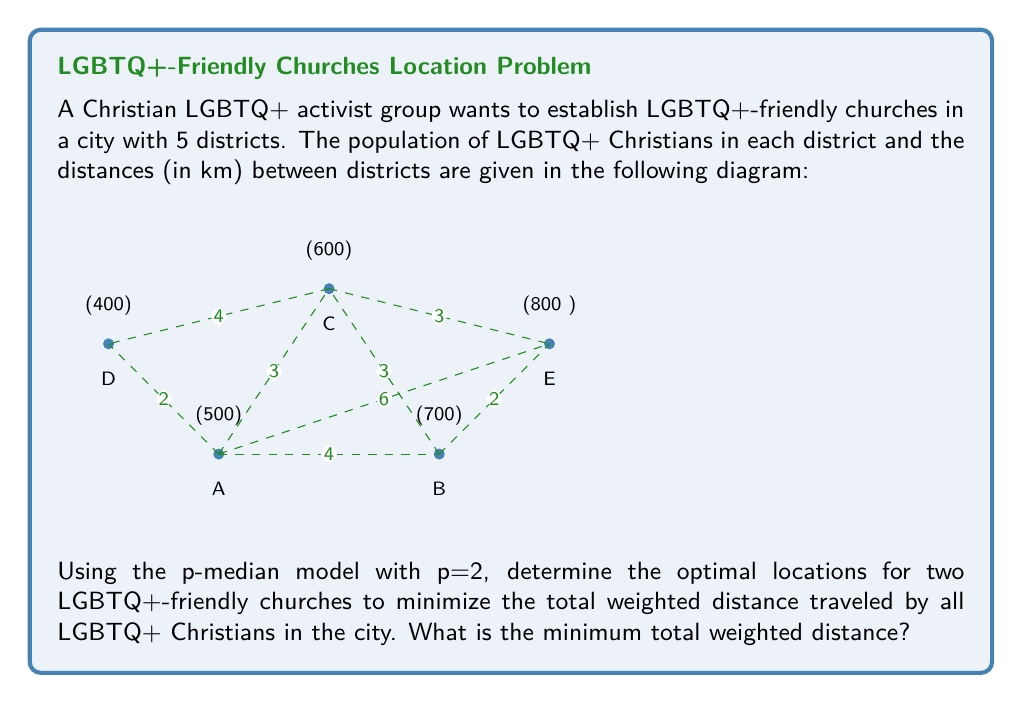Provide a solution to this math problem. To solve this problem using the p-median model, we need to follow these steps:

1) First, we need to calculate the weighted distances for all possible combinations of church locations. The weight for each district is its population.

2) For each combination of two districts as church locations, we calculate:
   $$ \text{Total Weighted Distance} = \sum_{i=1}^5 w_i \cdot \min(d_{i,j}, d_{i,k}) $$
   where $w_i$ is the population of district $i$, and $j$ and $k$ are the chosen church locations.

3) Let's calculate for each combination:

   AB: 500(0) + 700(0) + 600(3) + 400(2) + 800(2) = 4000
   AC: 500(0) + 700(3) + 600(0) + 400(4) + 800(3) = 4900
   AD: 500(0) + 700(4) + 600(3) + 400(0) + 800(6) = 7700
   AE: 500(0) + 700(2) + 600(3) + 400(2) + 800(0) = 3400
   BC: 500(3) + 700(0) + 600(0) + 400(4) + 800(2) = 4100
   BD: 500(4) + 700(0) + 600(3) + 400(2) + 800(2) = 4400
   BE: 500(4) + 700(0) + 600(3) + 400(6) + 800(0) = 5000
   CD: 500(3) + 700(3) + 600(0) + 400(0) + 800(3) = 4500
   CE: 500(3) + 700(2) + 600(0) + 400(4) + 800(0) = 3700
   DE: 500(2) + 700(2) + 600(3) + 400(0) + 800(0) = 3700

4) The minimum total weighted distance is 3400, corresponding to locating the churches in districts A and E.
Answer: 3400 